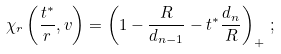Convert formula to latex. <formula><loc_0><loc_0><loc_500><loc_500>\chi _ { r } \left ( \frac { t ^ { * } } { r } , v \right ) = \left ( 1 - \frac { R } { d _ { n - 1 } } - t ^ { * } \frac { d _ { n } } { R } \right ) _ { + } \, ;</formula> 